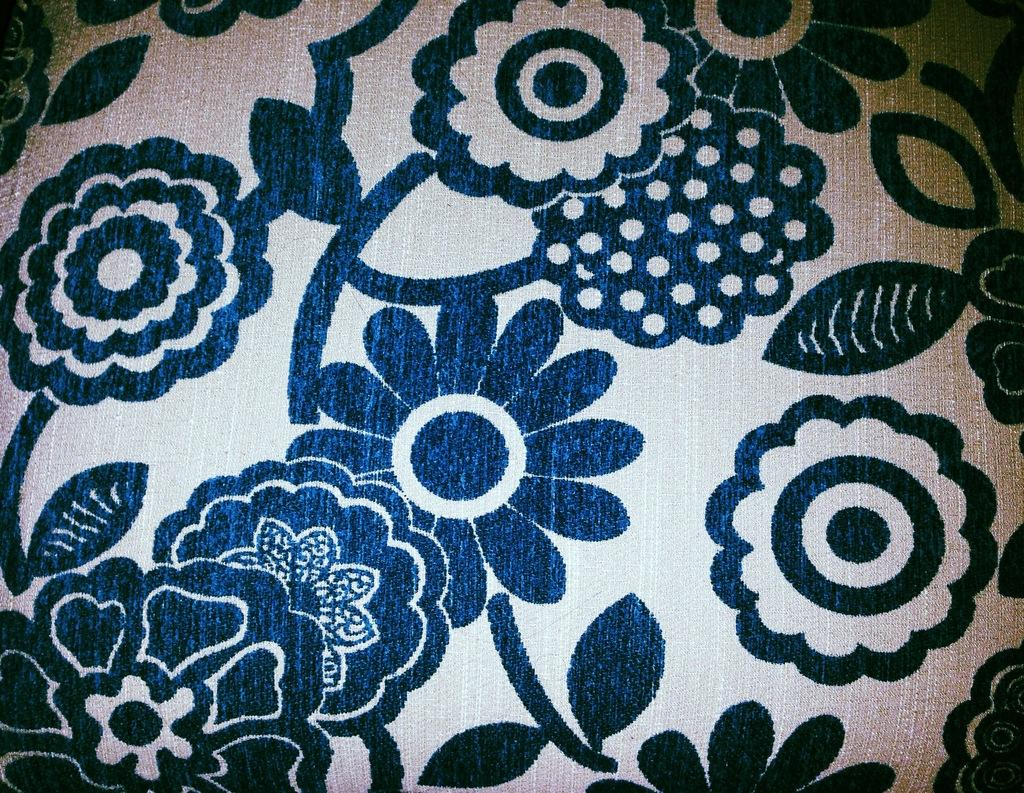What can be seen on the cloth in the image? There is a design on the cloth in the image. How many books are being lifted by the design on the cloth in the image? There are no books present in the image, and the design on the cloth is not interacting with any books. 